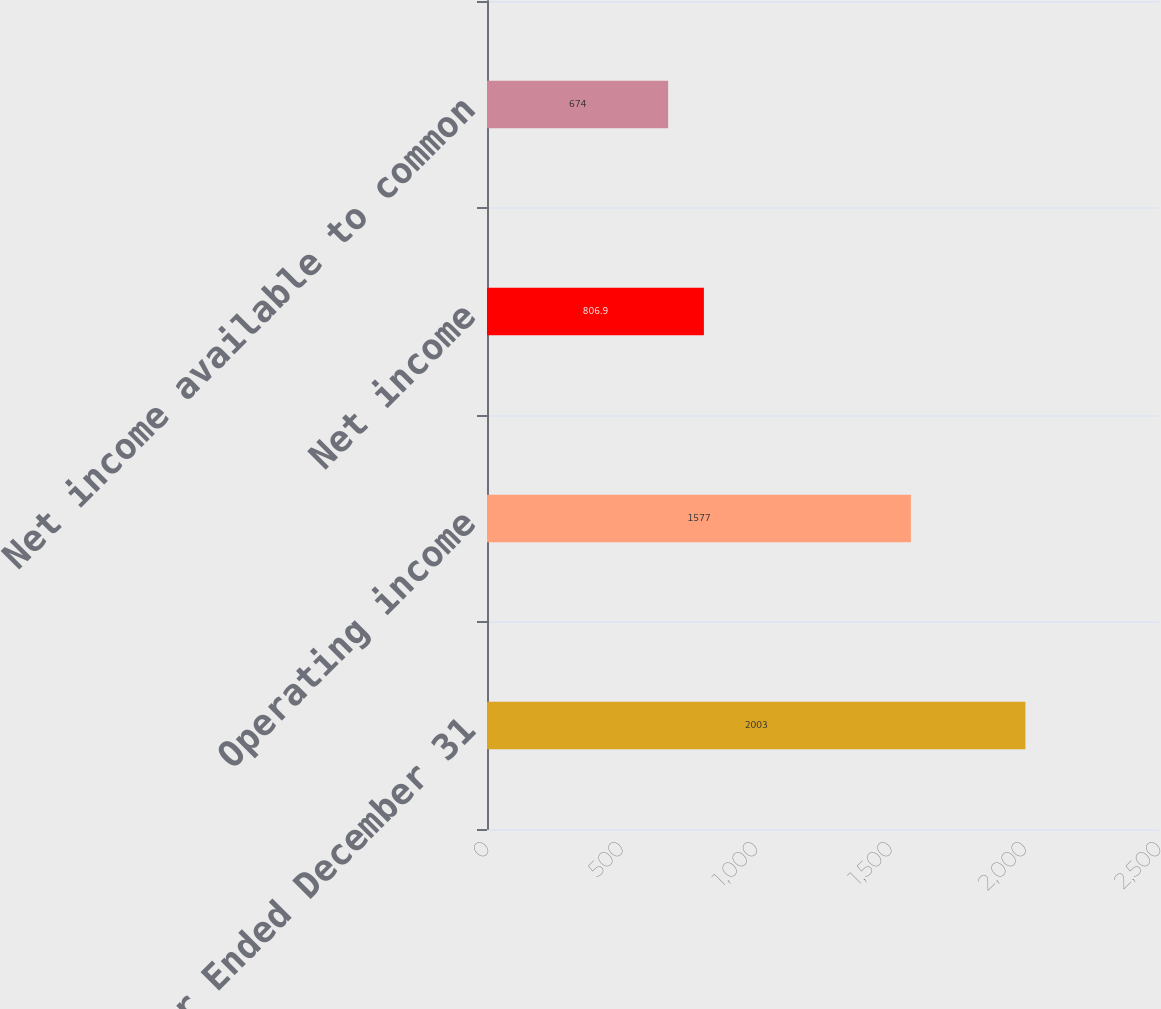<chart> <loc_0><loc_0><loc_500><loc_500><bar_chart><fcel>Year Ended December 31<fcel>Operating income<fcel>Net income<fcel>Net income available to common<nl><fcel>2003<fcel>1577<fcel>806.9<fcel>674<nl></chart> 